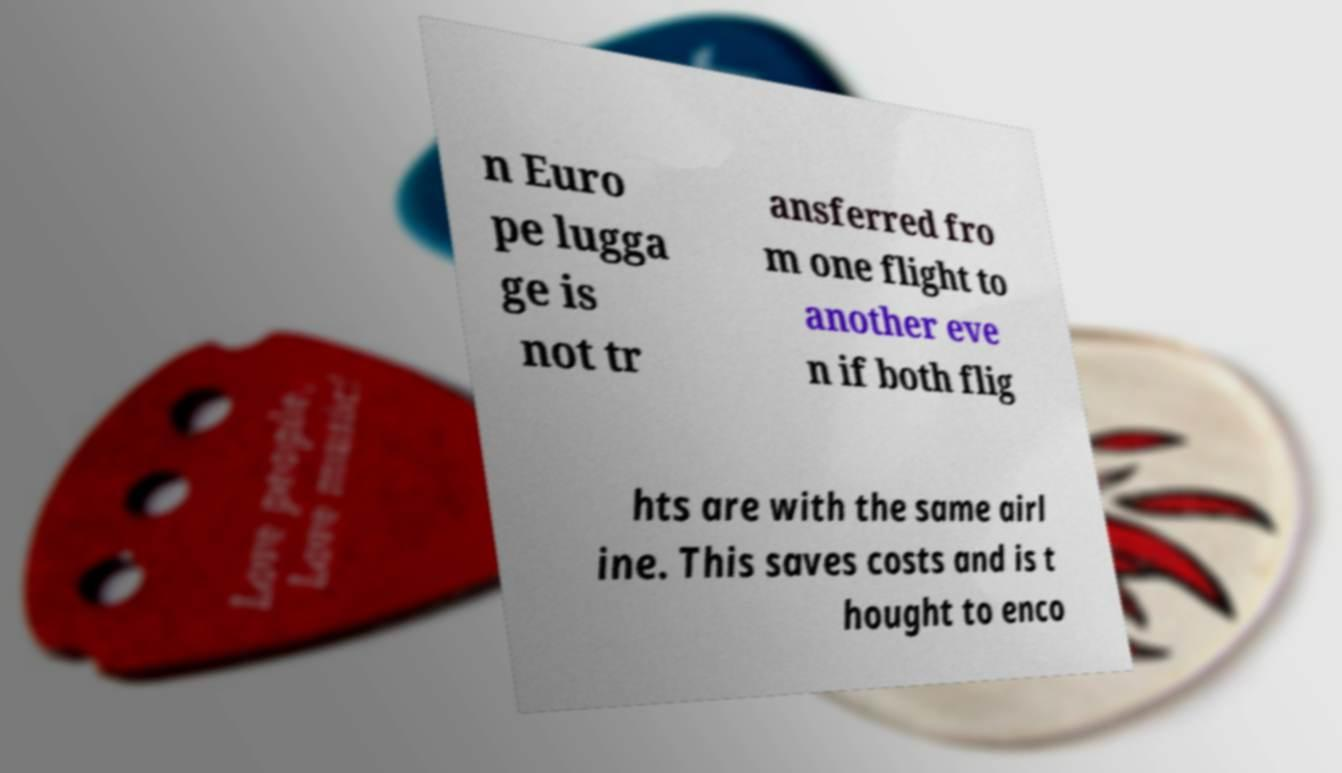There's text embedded in this image that I need extracted. Can you transcribe it verbatim? n Euro pe lugga ge is not tr ansferred fro m one flight to another eve n if both flig hts are with the same airl ine. This saves costs and is t hought to enco 